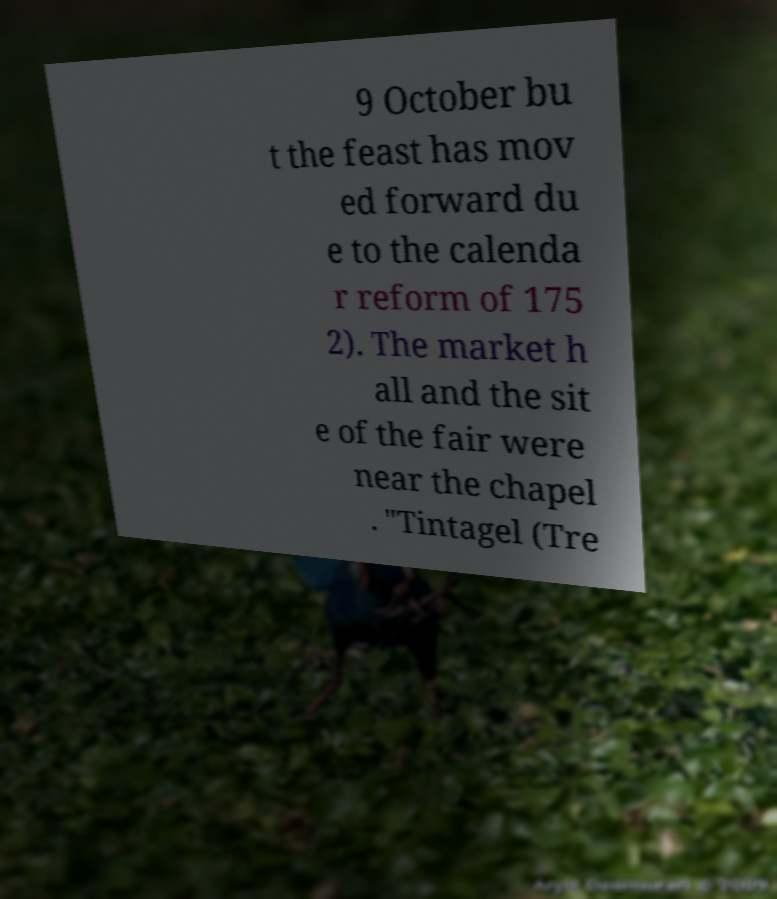There's text embedded in this image that I need extracted. Can you transcribe it verbatim? 9 October bu t the feast has mov ed forward du e to the calenda r reform of 175 2). The market h all and the sit e of the fair were near the chapel . "Tintagel (Tre 